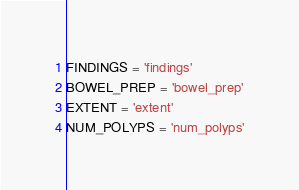Convert code to text. <code><loc_0><loc_0><loc_500><loc_500><_Python_>FINDINGS = 'findings'
BOWEL_PREP = 'bowel_prep'
EXTENT = 'extent'
NUM_POLYPS = 'num_polyps'
</code> 